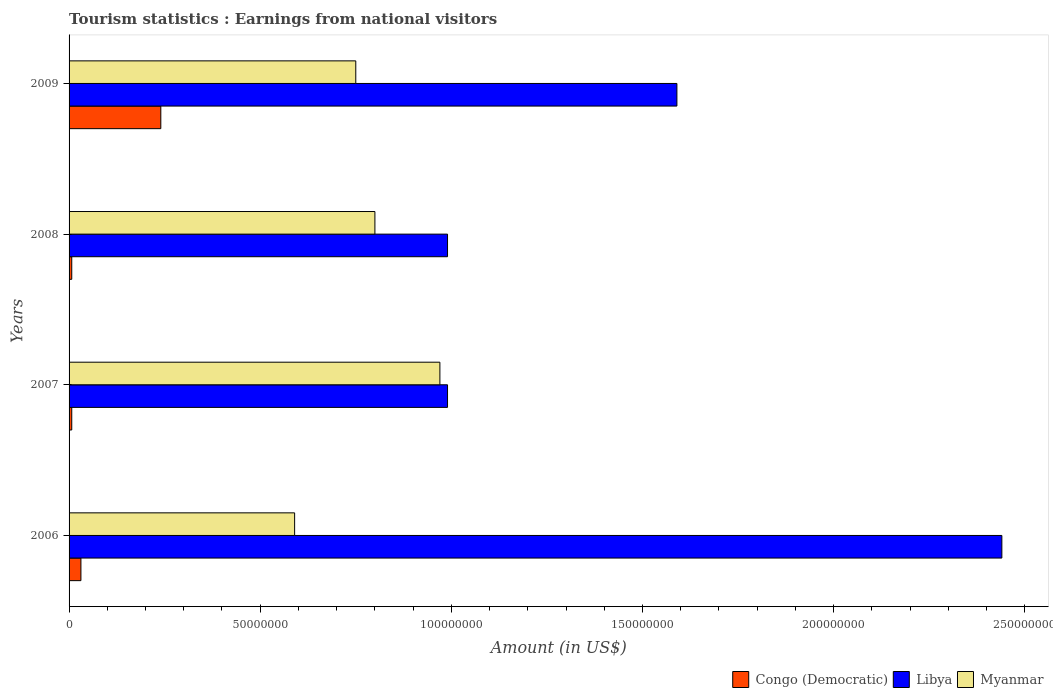How many different coloured bars are there?
Make the answer very short. 3. How many groups of bars are there?
Keep it short and to the point. 4. Are the number of bars per tick equal to the number of legend labels?
Ensure brevity in your answer.  Yes. What is the earnings from national visitors in Myanmar in 2006?
Offer a terse response. 5.90e+07. Across all years, what is the maximum earnings from national visitors in Libya?
Your answer should be very brief. 2.44e+08. Across all years, what is the minimum earnings from national visitors in Libya?
Keep it short and to the point. 9.90e+07. In which year was the earnings from national visitors in Myanmar maximum?
Make the answer very short. 2007. What is the total earnings from national visitors in Myanmar in the graph?
Ensure brevity in your answer.  3.11e+08. What is the difference between the earnings from national visitors in Myanmar in 2006 and that in 2008?
Provide a short and direct response. -2.10e+07. What is the difference between the earnings from national visitors in Libya in 2009 and the earnings from national visitors in Congo (Democratic) in 2008?
Your answer should be very brief. 1.58e+08. What is the average earnings from national visitors in Myanmar per year?
Your response must be concise. 7.78e+07. In the year 2006, what is the difference between the earnings from national visitors in Libya and earnings from national visitors in Myanmar?
Keep it short and to the point. 1.85e+08. In how many years, is the earnings from national visitors in Myanmar greater than 40000000 US$?
Your answer should be compact. 4. What is the ratio of the earnings from national visitors in Congo (Democratic) in 2008 to that in 2009?
Make the answer very short. 0.03. What is the difference between the highest and the second highest earnings from national visitors in Congo (Democratic)?
Provide a succinct answer. 2.09e+07. What is the difference between the highest and the lowest earnings from national visitors in Myanmar?
Your response must be concise. 3.80e+07. What does the 2nd bar from the top in 2008 represents?
Your response must be concise. Libya. What does the 1st bar from the bottom in 2007 represents?
Your answer should be very brief. Congo (Democratic). Is it the case that in every year, the sum of the earnings from national visitors in Congo (Democratic) and earnings from national visitors in Myanmar is greater than the earnings from national visitors in Libya?
Offer a very short reply. No. How many bars are there?
Give a very brief answer. 12. Are all the bars in the graph horizontal?
Keep it short and to the point. Yes. Are the values on the major ticks of X-axis written in scientific E-notation?
Keep it short and to the point. No. How are the legend labels stacked?
Give a very brief answer. Horizontal. What is the title of the graph?
Provide a succinct answer. Tourism statistics : Earnings from national visitors. What is the label or title of the Y-axis?
Make the answer very short. Years. What is the Amount (in US$) in Congo (Democratic) in 2006?
Your answer should be compact. 3.10e+06. What is the Amount (in US$) of Libya in 2006?
Ensure brevity in your answer.  2.44e+08. What is the Amount (in US$) of Myanmar in 2006?
Provide a short and direct response. 5.90e+07. What is the Amount (in US$) of Libya in 2007?
Give a very brief answer. 9.90e+07. What is the Amount (in US$) of Myanmar in 2007?
Keep it short and to the point. 9.70e+07. What is the Amount (in US$) of Congo (Democratic) in 2008?
Provide a short and direct response. 7.00e+05. What is the Amount (in US$) in Libya in 2008?
Your answer should be very brief. 9.90e+07. What is the Amount (in US$) in Myanmar in 2008?
Provide a short and direct response. 8.00e+07. What is the Amount (in US$) of Congo (Democratic) in 2009?
Offer a terse response. 2.40e+07. What is the Amount (in US$) in Libya in 2009?
Ensure brevity in your answer.  1.59e+08. What is the Amount (in US$) of Myanmar in 2009?
Offer a terse response. 7.50e+07. Across all years, what is the maximum Amount (in US$) of Congo (Democratic)?
Provide a short and direct response. 2.40e+07. Across all years, what is the maximum Amount (in US$) of Libya?
Ensure brevity in your answer.  2.44e+08. Across all years, what is the maximum Amount (in US$) in Myanmar?
Offer a very short reply. 9.70e+07. Across all years, what is the minimum Amount (in US$) of Libya?
Your answer should be very brief. 9.90e+07. Across all years, what is the minimum Amount (in US$) in Myanmar?
Ensure brevity in your answer.  5.90e+07. What is the total Amount (in US$) of Congo (Democratic) in the graph?
Your answer should be very brief. 2.85e+07. What is the total Amount (in US$) of Libya in the graph?
Your response must be concise. 6.01e+08. What is the total Amount (in US$) of Myanmar in the graph?
Your answer should be compact. 3.11e+08. What is the difference between the Amount (in US$) of Congo (Democratic) in 2006 and that in 2007?
Ensure brevity in your answer.  2.40e+06. What is the difference between the Amount (in US$) of Libya in 2006 and that in 2007?
Provide a succinct answer. 1.45e+08. What is the difference between the Amount (in US$) in Myanmar in 2006 and that in 2007?
Provide a succinct answer. -3.80e+07. What is the difference between the Amount (in US$) of Congo (Democratic) in 2006 and that in 2008?
Offer a terse response. 2.40e+06. What is the difference between the Amount (in US$) in Libya in 2006 and that in 2008?
Ensure brevity in your answer.  1.45e+08. What is the difference between the Amount (in US$) of Myanmar in 2006 and that in 2008?
Provide a succinct answer. -2.10e+07. What is the difference between the Amount (in US$) of Congo (Democratic) in 2006 and that in 2009?
Your response must be concise. -2.09e+07. What is the difference between the Amount (in US$) in Libya in 2006 and that in 2009?
Your response must be concise. 8.50e+07. What is the difference between the Amount (in US$) in Myanmar in 2006 and that in 2009?
Your answer should be compact. -1.60e+07. What is the difference between the Amount (in US$) in Myanmar in 2007 and that in 2008?
Your response must be concise. 1.70e+07. What is the difference between the Amount (in US$) in Congo (Democratic) in 2007 and that in 2009?
Your answer should be compact. -2.33e+07. What is the difference between the Amount (in US$) in Libya in 2007 and that in 2009?
Provide a short and direct response. -6.00e+07. What is the difference between the Amount (in US$) in Myanmar in 2007 and that in 2009?
Offer a very short reply. 2.20e+07. What is the difference between the Amount (in US$) in Congo (Democratic) in 2008 and that in 2009?
Your answer should be very brief. -2.33e+07. What is the difference between the Amount (in US$) in Libya in 2008 and that in 2009?
Your answer should be very brief. -6.00e+07. What is the difference between the Amount (in US$) in Myanmar in 2008 and that in 2009?
Your response must be concise. 5.00e+06. What is the difference between the Amount (in US$) of Congo (Democratic) in 2006 and the Amount (in US$) of Libya in 2007?
Your answer should be very brief. -9.59e+07. What is the difference between the Amount (in US$) in Congo (Democratic) in 2006 and the Amount (in US$) in Myanmar in 2007?
Offer a terse response. -9.39e+07. What is the difference between the Amount (in US$) of Libya in 2006 and the Amount (in US$) of Myanmar in 2007?
Offer a terse response. 1.47e+08. What is the difference between the Amount (in US$) of Congo (Democratic) in 2006 and the Amount (in US$) of Libya in 2008?
Provide a short and direct response. -9.59e+07. What is the difference between the Amount (in US$) in Congo (Democratic) in 2006 and the Amount (in US$) in Myanmar in 2008?
Your answer should be very brief. -7.69e+07. What is the difference between the Amount (in US$) of Libya in 2006 and the Amount (in US$) of Myanmar in 2008?
Provide a succinct answer. 1.64e+08. What is the difference between the Amount (in US$) of Congo (Democratic) in 2006 and the Amount (in US$) of Libya in 2009?
Provide a succinct answer. -1.56e+08. What is the difference between the Amount (in US$) of Congo (Democratic) in 2006 and the Amount (in US$) of Myanmar in 2009?
Keep it short and to the point. -7.19e+07. What is the difference between the Amount (in US$) of Libya in 2006 and the Amount (in US$) of Myanmar in 2009?
Your response must be concise. 1.69e+08. What is the difference between the Amount (in US$) in Congo (Democratic) in 2007 and the Amount (in US$) in Libya in 2008?
Provide a short and direct response. -9.83e+07. What is the difference between the Amount (in US$) of Congo (Democratic) in 2007 and the Amount (in US$) of Myanmar in 2008?
Provide a short and direct response. -7.93e+07. What is the difference between the Amount (in US$) of Libya in 2007 and the Amount (in US$) of Myanmar in 2008?
Offer a very short reply. 1.90e+07. What is the difference between the Amount (in US$) in Congo (Democratic) in 2007 and the Amount (in US$) in Libya in 2009?
Offer a very short reply. -1.58e+08. What is the difference between the Amount (in US$) in Congo (Democratic) in 2007 and the Amount (in US$) in Myanmar in 2009?
Offer a very short reply. -7.43e+07. What is the difference between the Amount (in US$) in Libya in 2007 and the Amount (in US$) in Myanmar in 2009?
Your response must be concise. 2.40e+07. What is the difference between the Amount (in US$) of Congo (Democratic) in 2008 and the Amount (in US$) of Libya in 2009?
Ensure brevity in your answer.  -1.58e+08. What is the difference between the Amount (in US$) in Congo (Democratic) in 2008 and the Amount (in US$) in Myanmar in 2009?
Your response must be concise. -7.43e+07. What is the difference between the Amount (in US$) of Libya in 2008 and the Amount (in US$) of Myanmar in 2009?
Provide a short and direct response. 2.40e+07. What is the average Amount (in US$) in Congo (Democratic) per year?
Provide a succinct answer. 7.12e+06. What is the average Amount (in US$) in Libya per year?
Provide a short and direct response. 1.50e+08. What is the average Amount (in US$) in Myanmar per year?
Keep it short and to the point. 7.78e+07. In the year 2006, what is the difference between the Amount (in US$) in Congo (Democratic) and Amount (in US$) in Libya?
Your answer should be very brief. -2.41e+08. In the year 2006, what is the difference between the Amount (in US$) in Congo (Democratic) and Amount (in US$) in Myanmar?
Your answer should be compact. -5.59e+07. In the year 2006, what is the difference between the Amount (in US$) of Libya and Amount (in US$) of Myanmar?
Offer a terse response. 1.85e+08. In the year 2007, what is the difference between the Amount (in US$) of Congo (Democratic) and Amount (in US$) of Libya?
Give a very brief answer. -9.83e+07. In the year 2007, what is the difference between the Amount (in US$) in Congo (Democratic) and Amount (in US$) in Myanmar?
Ensure brevity in your answer.  -9.63e+07. In the year 2008, what is the difference between the Amount (in US$) of Congo (Democratic) and Amount (in US$) of Libya?
Give a very brief answer. -9.83e+07. In the year 2008, what is the difference between the Amount (in US$) in Congo (Democratic) and Amount (in US$) in Myanmar?
Provide a short and direct response. -7.93e+07. In the year 2008, what is the difference between the Amount (in US$) in Libya and Amount (in US$) in Myanmar?
Your response must be concise. 1.90e+07. In the year 2009, what is the difference between the Amount (in US$) of Congo (Democratic) and Amount (in US$) of Libya?
Give a very brief answer. -1.35e+08. In the year 2009, what is the difference between the Amount (in US$) in Congo (Democratic) and Amount (in US$) in Myanmar?
Provide a short and direct response. -5.10e+07. In the year 2009, what is the difference between the Amount (in US$) in Libya and Amount (in US$) in Myanmar?
Keep it short and to the point. 8.40e+07. What is the ratio of the Amount (in US$) of Congo (Democratic) in 2006 to that in 2007?
Your answer should be very brief. 4.43. What is the ratio of the Amount (in US$) of Libya in 2006 to that in 2007?
Ensure brevity in your answer.  2.46. What is the ratio of the Amount (in US$) in Myanmar in 2006 to that in 2007?
Ensure brevity in your answer.  0.61. What is the ratio of the Amount (in US$) of Congo (Democratic) in 2006 to that in 2008?
Offer a terse response. 4.43. What is the ratio of the Amount (in US$) of Libya in 2006 to that in 2008?
Provide a succinct answer. 2.46. What is the ratio of the Amount (in US$) of Myanmar in 2006 to that in 2008?
Ensure brevity in your answer.  0.74. What is the ratio of the Amount (in US$) of Congo (Democratic) in 2006 to that in 2009?
Offer a terse response. 0.13. What is the ratio of the Amount (in US$) of Libya in 2006 to that in 2009?
Your answer should be compact. 1.53. What is the ratio of the Amount (in US$) of Myanmar in 2006 to that in 2009?
Your answer should be compact. 0.79. What is the ratio of the Amount (in US$) of Myanmar in 2007 to that in 2008?
Provide a short and direct response. 1.21. What is the ratio of the Amount (in US$) of Congo (Democratic) in 2007 to that in 2009?
Give a very brief answer. 0.03. What is the ratio of the Amount (in US$) of Libya in 2007 to that in 2009?
Your response must be concise. 0.62. What is the ratio of the Amount (in US$) of Myanmar in 2007 to that in 2009?
Provide a succinct answer. 1.29. What is the ratio of the Amount (in US$) of Congo (Democratic) in 2008 to that in 2009?
Make the answer very short. 0.03. What is the ratio of the Amount (in US$) in Libya in 2008 to that in 2009?
Ensure brevity in your answer.  0.62. What is the ratio of the Amount (in US$) of Myanmar in 2008 to that in 2009?
Make the answer very short. 1.07. What is the difference between the highest and the second highest Amount (in US$) of Congo (Democratic)?
Keep it short and to the point. 2.09e+07. What is the difference between the highest and the second highest Amount (in US$) of Libya?
Offer a terse response. 8.50e+07. What is the difference between the highest and the second highest Amount (in US$) of Myanmar?
Keep it short and to the point. 1.70e+07. What is the difference between the highest and the lowest Amount (in US$) in Congo (Democratic)?
Make the answer very short. 2.33e+07. What is the difference between the highest and the lowest Amount (in US$) in Libya?
Offer a very short reply. 1.45e+08. What is the difference between the highest and the lowest Amount (in US$) in Myanmar?
Give a very brief answer. 3.80e+07. 